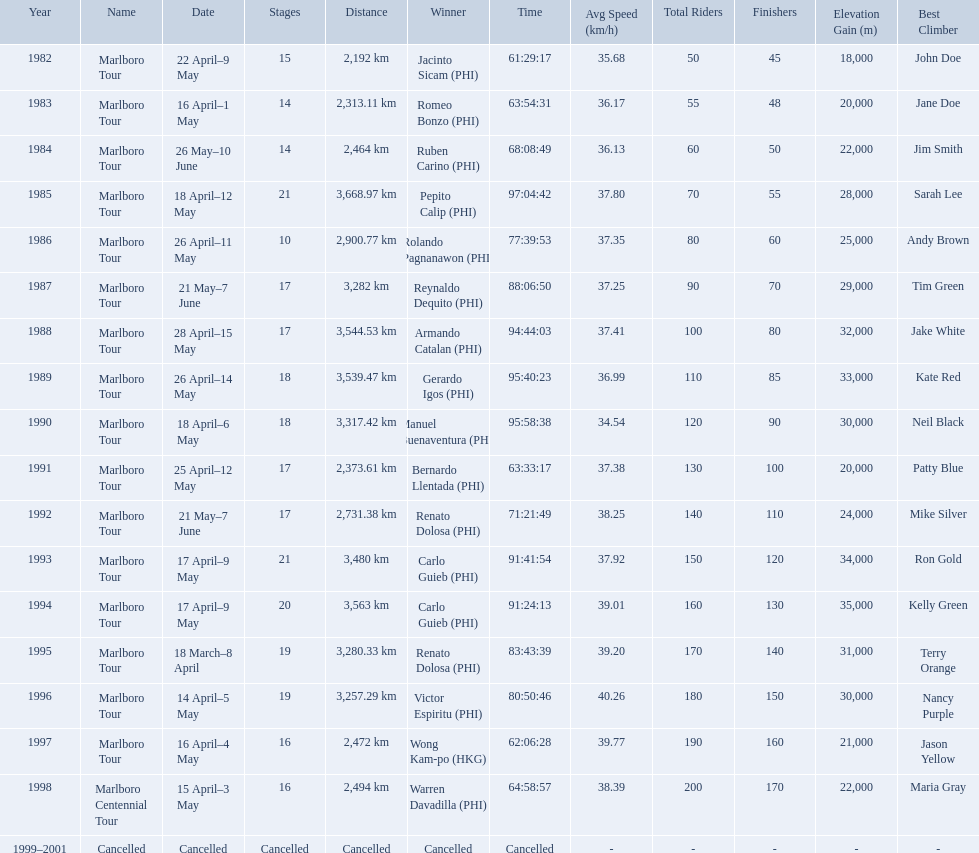What are the distances travelled on the tour? 2,192 km, 2,313.11 km, 2,464 km, 3,668.97 km, 2,900.77 km, 3,282 km, 3,544.53 km, 3,539.47 km, 3,317.42 km, 2,373.61 km, 2,731.38 km, 3,480 km, 3,563 km, 3,280.33 km, 3,257.29 km, 2,472 km, 2,494 km. Which of these are the largest? 3,668.97 km. What were the tour names during le tour de filipinas? Marlboro Tour, Marlboro Tour, Marlboro Tour, Marlboro Tour, Marlboro Tour, Marlboro Tour, Marlboro Tour, Marlboro Tour, Marlboro Tour, Marlboro Tour, Marlboro Tour, Marlboro Tour, Marlboro Tour, Marlboro Tour, Marlboro Tour, Marlboro Tour, Marlboro Centennial Tour, Cancelled. What were the recorded distances for each marlboro tour? 2,192 km, 2,313.11 km, 2,464 km, 3,668.97 km, 2,900.77 km, 3,282 km, 3,544.53 km, 3,539.47 km, 3,317.42 km, 2,373.61 km, 2,731.38 km, 3,480 km, 3,563 km, 3,280.33 km, 3,257.29 km, 2,472 km. And of those distances, which was the longest? 3,668.97 km. Which year did warren davdilla (w.d.) appear? 1998. What tour did w.d. complete? Marlboro Centennial Tour. What is the time recorded in the same row as w.d.? 64:58:57. 